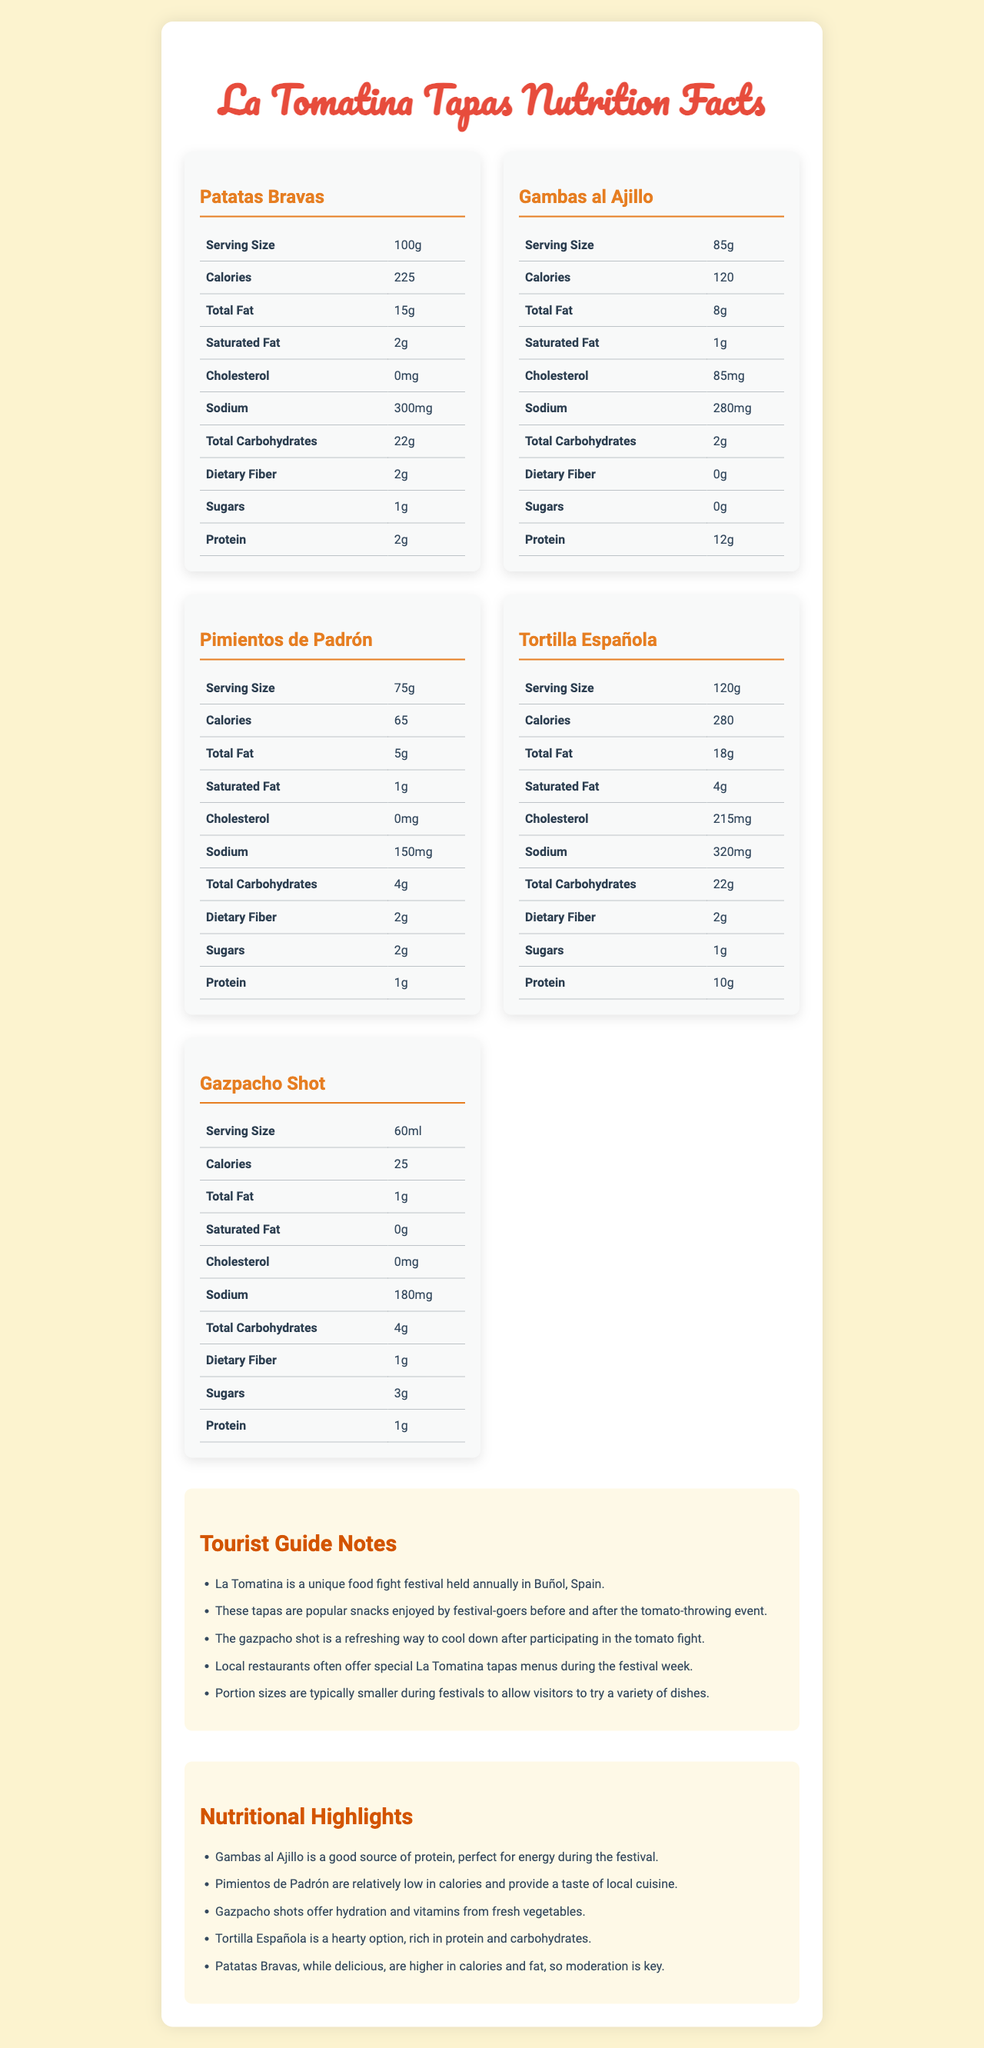what is the serving size of Patatas Bravas? The document lists the serving size of Patatas Bravas as 100g in the nutrition table.
Answer: 100g which tapas has the highest calories per serving? A. Tortilla Española B. Patatas Bravas C. Gambas al Ajillo Tortilla Española has 280 calories, which is the highest compared to Patatas Bravas (225 calories) and Gambas al Ajillo (120 calories).
Answer: A is the Cholesterol in Patatas Bravas higher than in Gambas al Ajillo? Yes/No The cholesterol content in Patatas Bravas is 0mg, while in Gambas al Ajillo it is 85mg.
Answer: No what is a good protein source for energy during La Tomatina? The guide notes state that Gambas al Ajillo is a good source of protein, which is ideal for energy during the festival.
Answer: Gambas al Ajillo name one tapa that is a good choice for hydration and vitamins The nutritional highlights mention that Gazpacho shots offer hydration and vitamins from fresh vegetables.
Answer: Gazpacho Shot how much total fat is in a serving of Pimientos de Padrón? The nutrition table indicates that a serving of Pimientos de Padrón contains 5g of total fat.
Answer: 5g which tapa has the lowest sodium content? A. Gazpacho Shot B. Pimientos de Padrón C. Gambas al Ajillo Pimientos de Padrón has 150mg of sodium, which is lower than Gazpacho Shot (180mg) and Gambas al Ajillo (280mg).
Answer: B does Tortilla Española contain dietary fiber? The nutrition table shows that Tortilla Española contains 2g of dietary fiber.
Answer: Yes summarize the main idea of the document. The document is aimed at helping festival-goers make informed choices about the tapas they consume at La Tomatina, highlighting key nutritional benefits and providing notes from a tourist guide.
Answer: The document provides nutritional information about various tapas commonly found at La Tomatina festival in Buñol, Spain. It includes the calorie count and other nutritional values for each tapa as well as guide notes with insights for tourists. what is the percentage of carbohydrates in Patatas Bravas? The document provides the amount of total carbohydrates in grams but does not provide percentage information.
Answer: Cannot be determined which tapa is indicated for its low-calorie content in the guide notes? The guide notes highlight Pimientos de Padrón as being relatively low in calories and providing a taste of local cuisine.
Answer: Pimientos de Padrón what is the main festival discussed in this document? The document focuses on La Tomatina, a unique food fight festival held annually in Buñol, Spain.
Answer: La Tomatina how many grams of protein are in a serving of Gazpacho Shot? The nutrition table shows that a serving of Gazpacho Shot contains 1g of protein.
Answer: 1g 